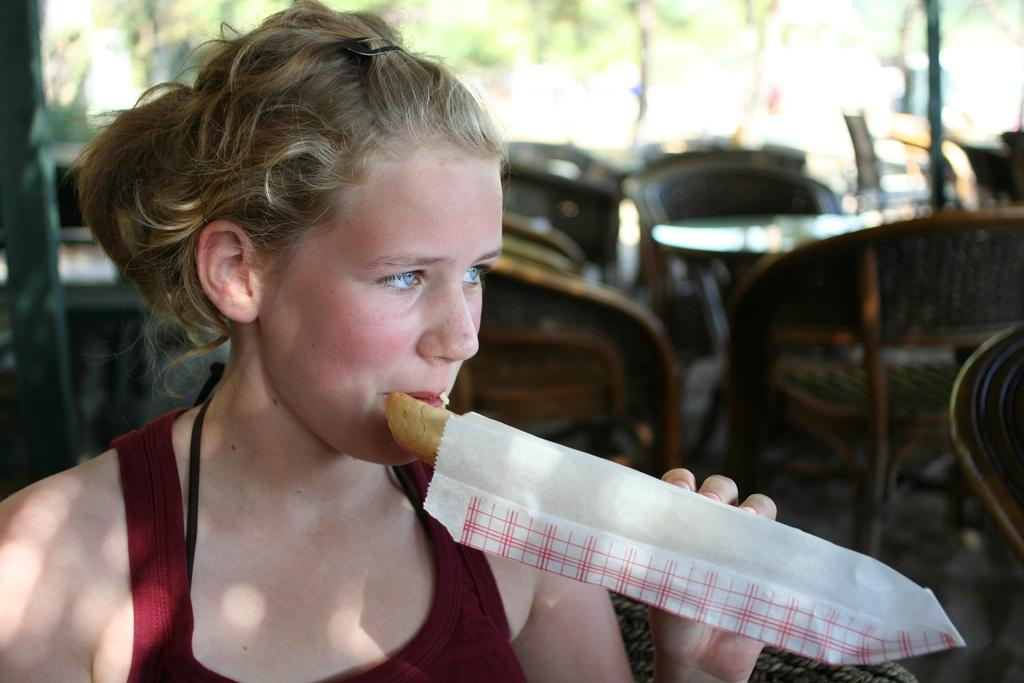Who is the main subject in the foreground of the image? There is a lady in the foreground of the image. What is the lady holding in the image? The lady is holding a food item. What type of furniture can be seen in the image? There are chairs and tables in the image. What can be seen in the background of the image? There appears to be bamboo and greenery in the background. Can you see any popcorn in the image? There is no popcorn present in the image. Does the lady have fangs in the image? The lady does not have fangs in the image; she is holding a food item. 